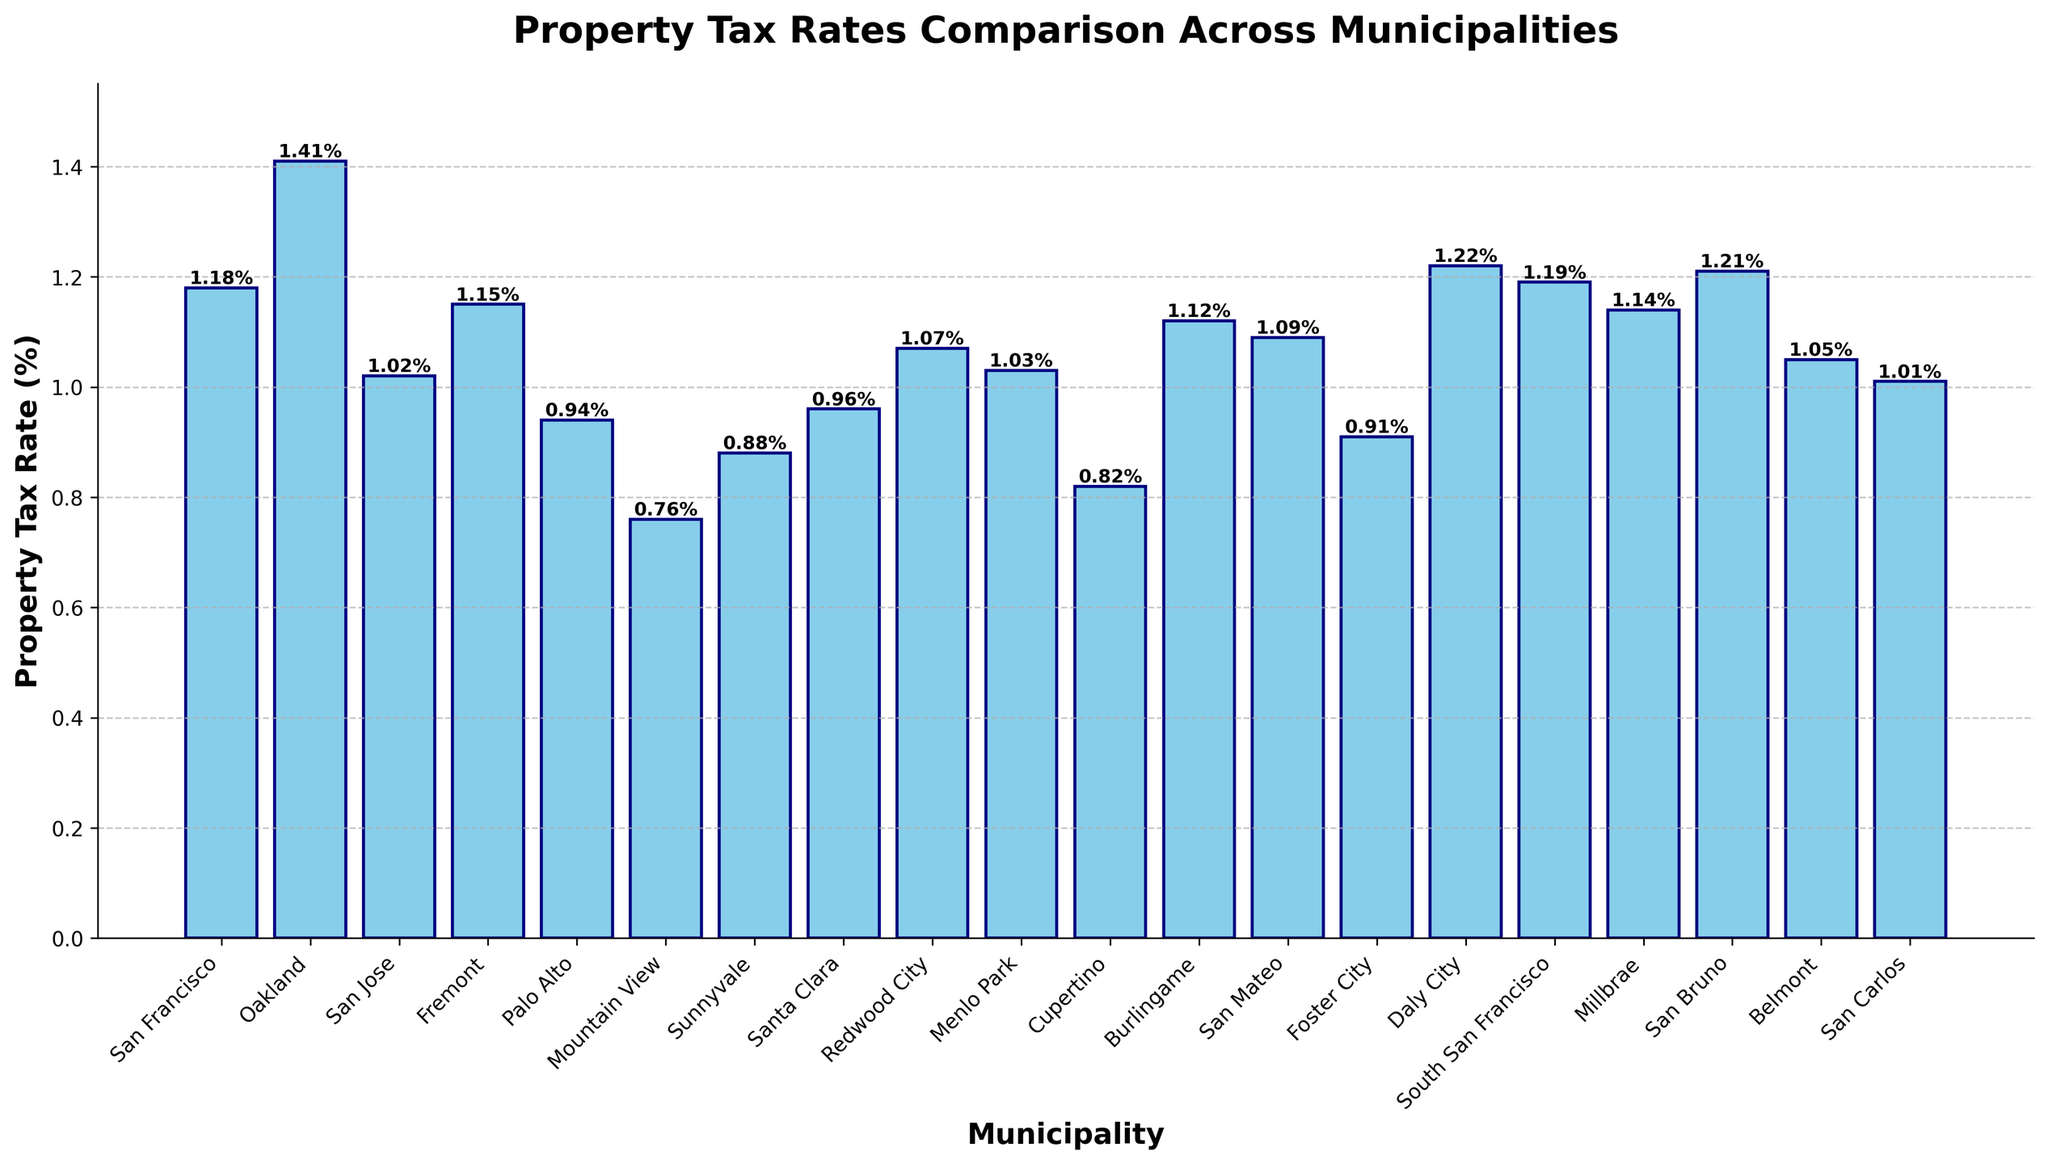Which municipality has the highest property tax rate? By examining the heights of the bars, we find that Oakland has the tallest bar, indicating the highest property tax rate of 1.41%.
Answer: Oakland What is the property tax rate difference between the highest and lowest municipalities? The highest property tax rate is 1.41% (Oakland), and the lowest is 0.76% (Mountain View). The difference is calculated as 1.41% - 0.76% = 0.65%.
Answer: 0.65% How many municipalities have property tax rates above 1.00%? By checking the heights of the bars labeled with values above 1.00%, we find that 12 municipalities meet this criterion.
Answer: 12 Which municipalities have property tax rates equal to or less than 1.00%? By observing the bars and their height values, the municipalities with tax rates of 1.00% or less are San Jose, Palo Alto, Mountain View, Sunnyvale, Santa Clara, Menlo Park, Cupertino, Foster City, and San Carlos.
Answer: 9 What is the average property tax rate of the three municipalities with the highest tax rates? The three highest rates are Oakland (1.41%), San Bruno (1.21%), and Daly City (1.22%). The average is (1.41% + 1.22% + 1.21%) / 3 = 1.28%.
Answer: 1.28% Are there any municipalities with property tax rates that are exactly 1.00%? By looking at the heights of the bars and their corresponding values, we see that San Carlos has a tax rate of exactly 1.00%.
Answer: Yes Compare the property tax rates of San Francisco and Milbrae. Which is higher and by how much? San Francisco has a property tax rate of 1.18%, and Millbrae has a rate of 1.14%. San Francisco's rate is higher by 1.18% - 1.14% = 0.04%.
Answer: San Francisco by 0.04% What is the combined property tax rate of Palo Alto and Cupertino? Adding the tax rates of Palo Alto (0.94%) and Cupertino (0.82%) results in a combined rate of 0.94% + 0.82% = 1.76%.
Answer: 1.76% Which municipality's property tax rate is closest to the average property tax rate of all listed municipalities? To find this, first calculate the average rate: (sum of all rates) / 20. The average is approximately: (1.18 + 1.41 + 1.02 + 1.15 + 0.94 + 0.76 + 0.88 + 0.96 + 1.07 + 1.03 + 0.82 + 1.12 + 1.09 + 0.91 + 1.22 + 1.19 + 1.14 + 1.21 + 1.05 + 1.01 ) / 20 = 1.05%. Belmont's rate of 1.05% matches exactly.
Answer: Belmont 